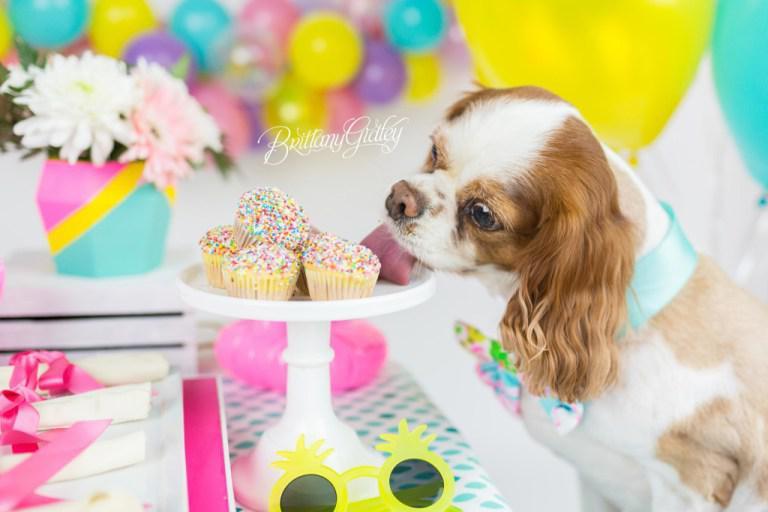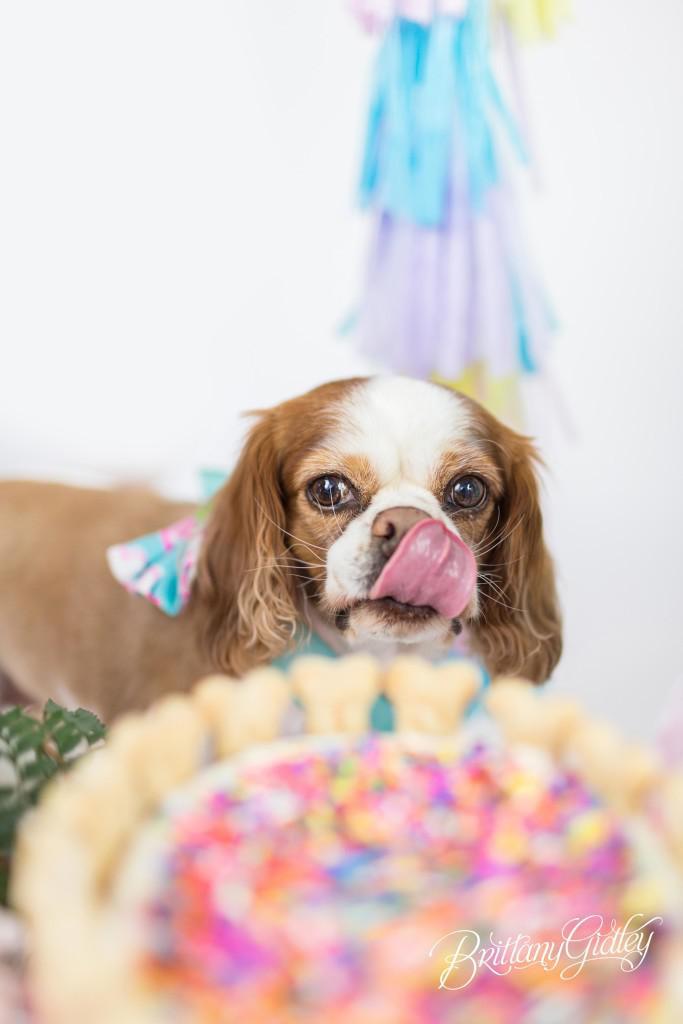The first image is the image on the left, the second image is the image on the right. Examine the images to the left and right. Is the description "A birthday hat has been placed on at least one puppy's head." accurate? Answer yes or no. No. The first image is the image on the left, the second image is the image on the right. For the images displayed, is the sentence "at least one dog in the image pair is wearing a party hat" factually correct? Answer yes or no. No. 